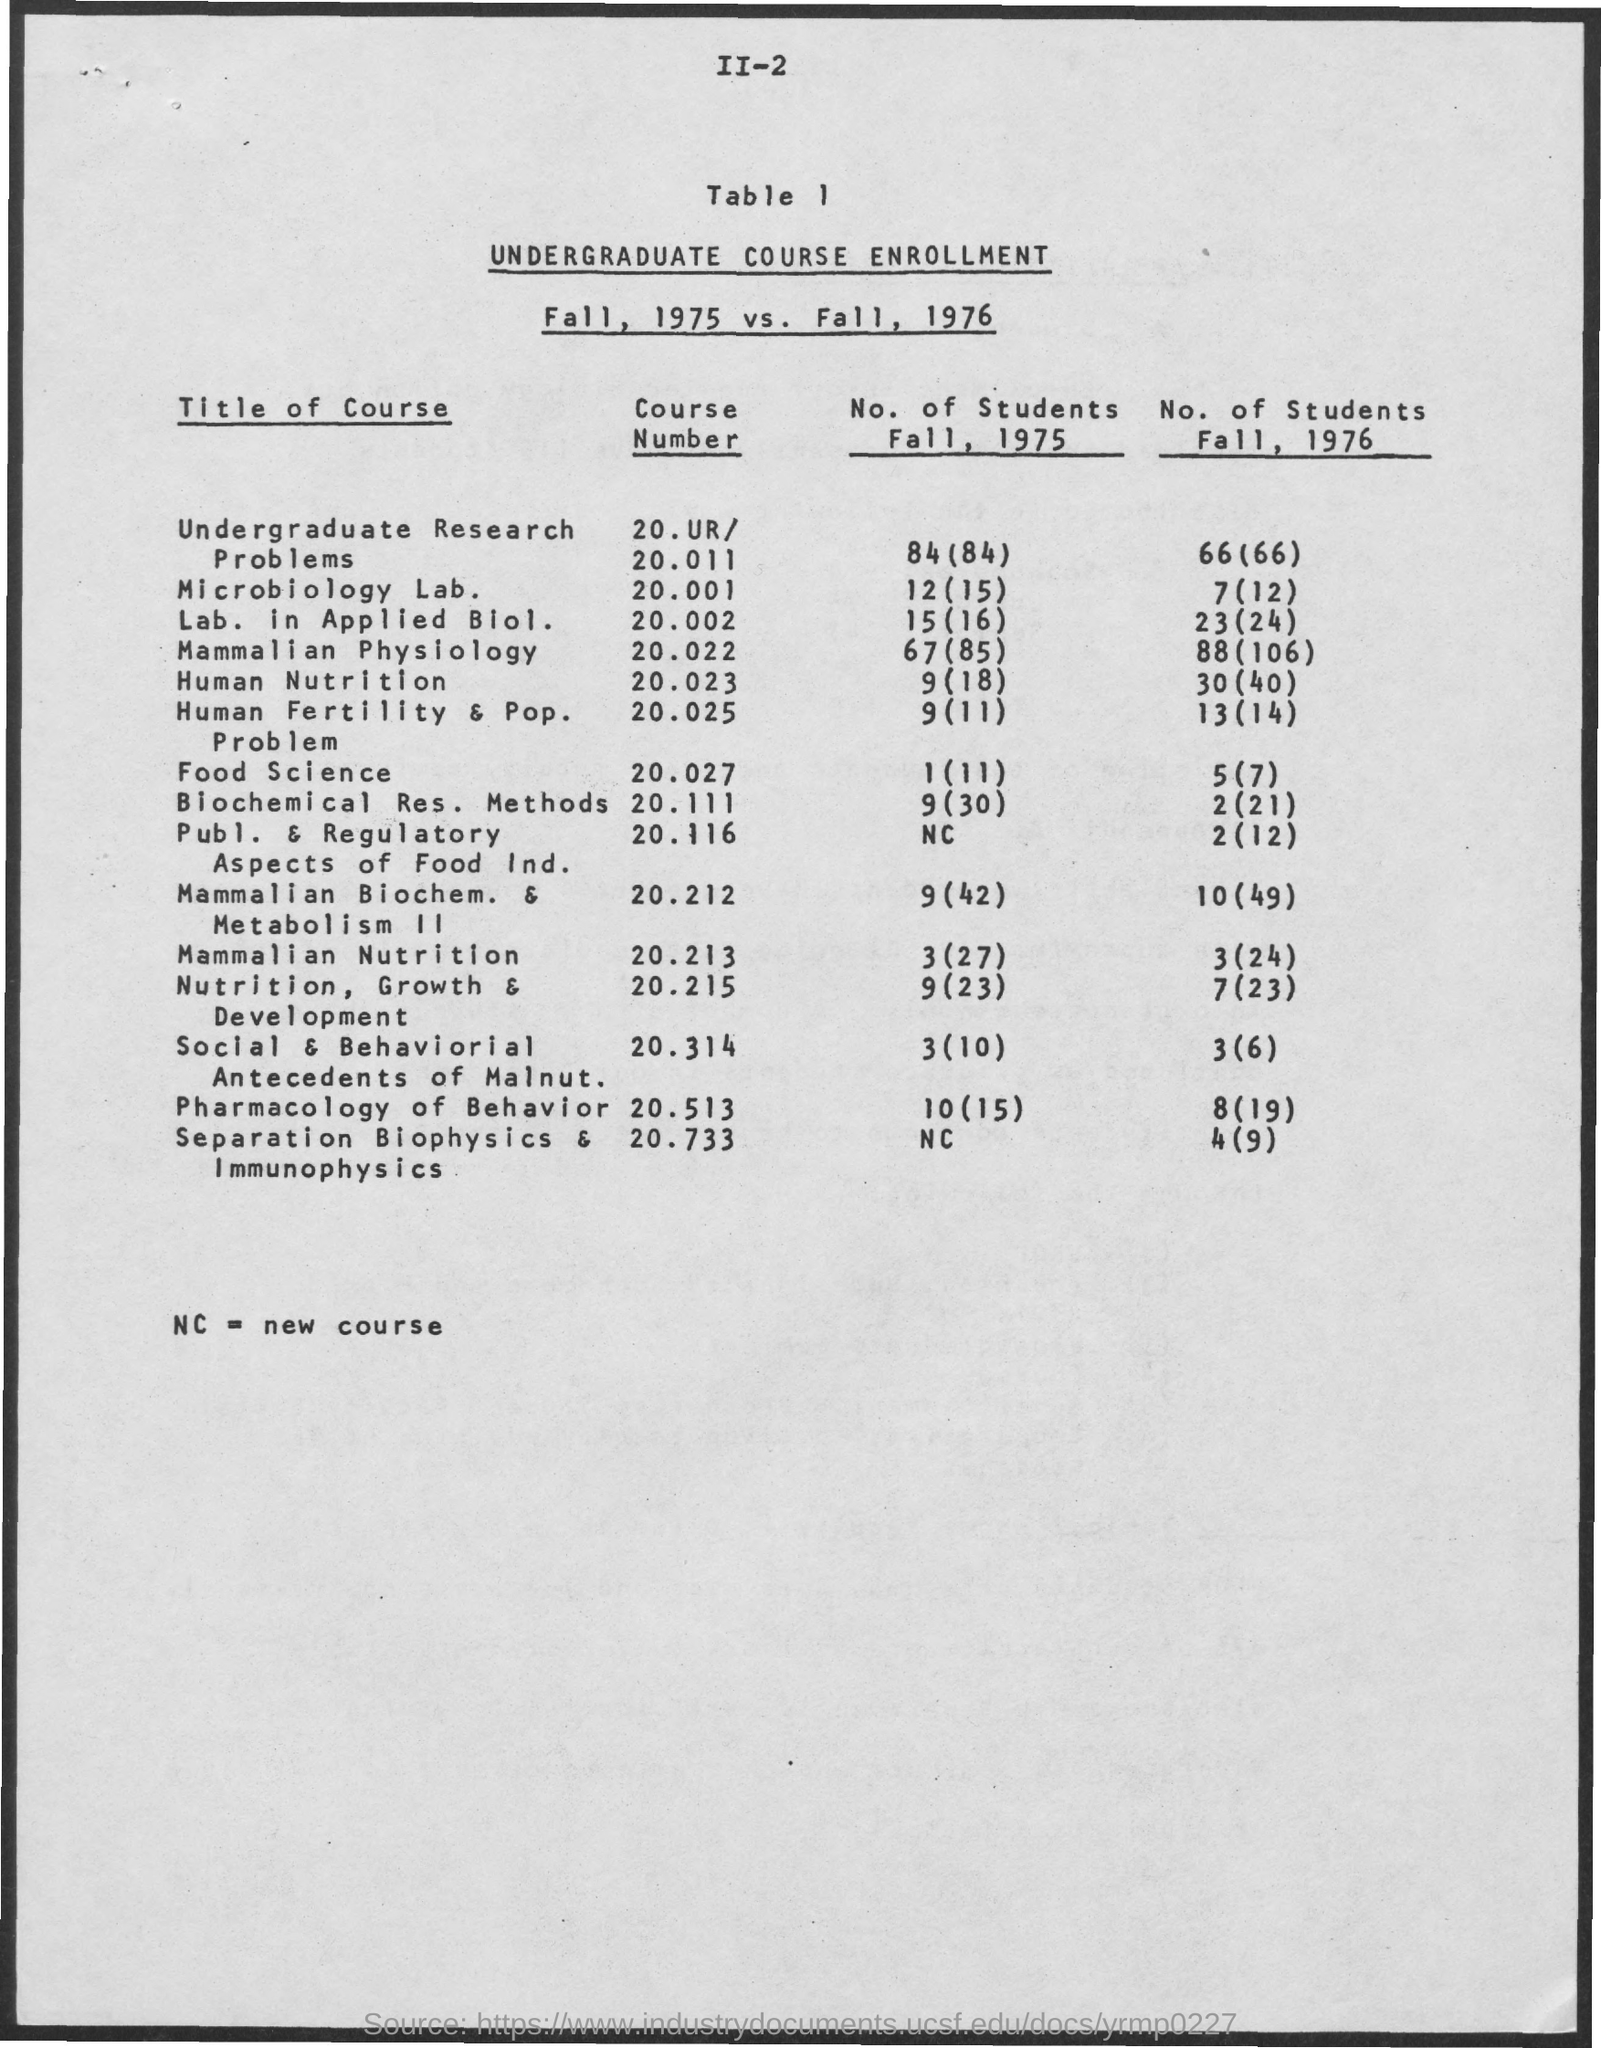What are the No. of Students Fall, 1975 for course Number 20.001?
Offer a terse response. 12(15). What are the No. of Students Fall, 1975 for course Number 20.011?
Offer a terse response. 84(84). What are the No. of Students Fall, 1975 for course Number 20.002?
Keep it short and to the point. 15(16). What are the No. of Students Fall, 1975 for course Number 20.022?
Give a very brief answer. 67(85). What are the No. of Students Fall, 1975 for course Number 20.023?
Provide a succinct answer. 9(18). What are the No. of Students Fall, 1975 for course Number 20.025?
Offer a very short reply. 9(11). What are the No. of Students Fall, 1975 for course Number 20.027?
Ensure brevity in your answer.  1(11). What are the No. of Students Fall, 1975 for course Number 20.111?
Provide a succinct answer. 9(30). What are the No. of Students Fall, 1975 for course Number 20.116?
Make the answer very short. NC. What are the No. of Students Fall, 1975 for course Number 20.212?
Give a very brief answer. 9(42). What are the No. of Students Fall, 1975 for course Number 20.213?
Your answer should be compact. 3(27). 